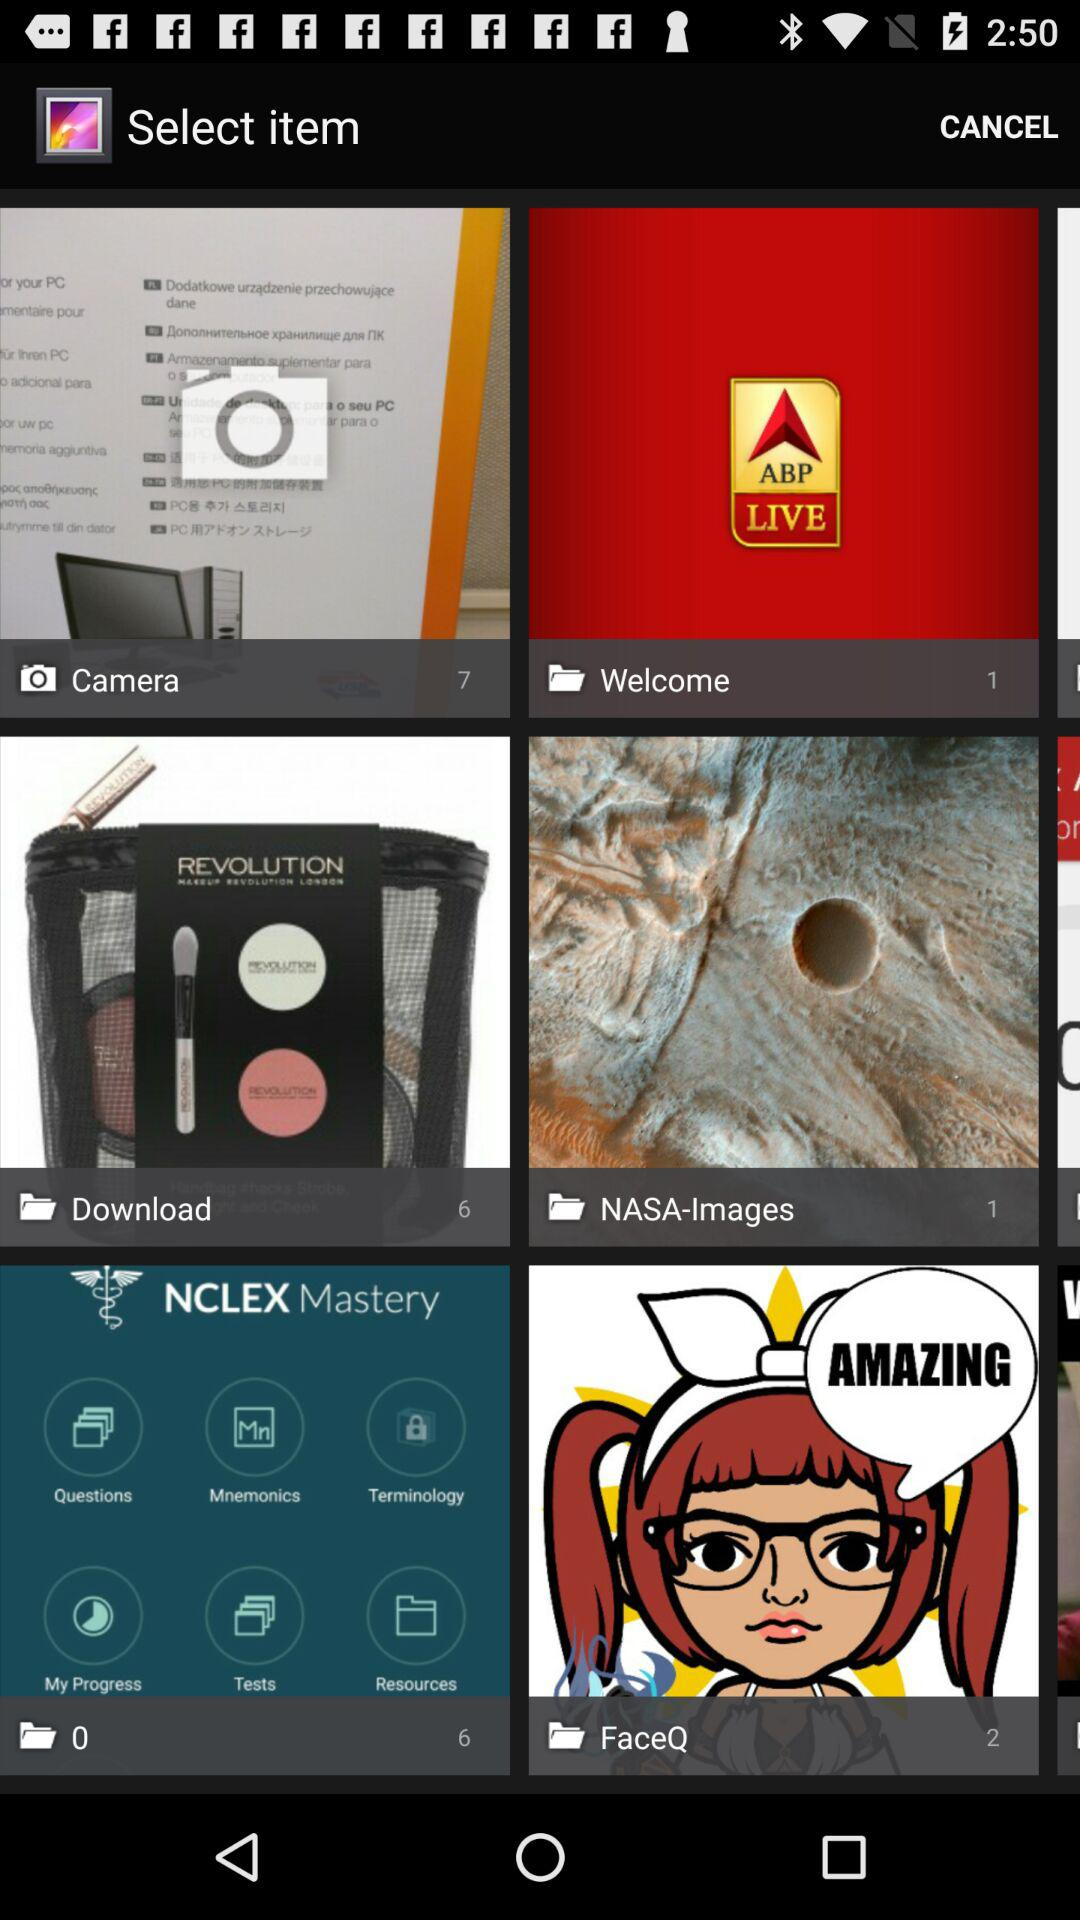How many items are in the "Camera"? There are 7 items. 